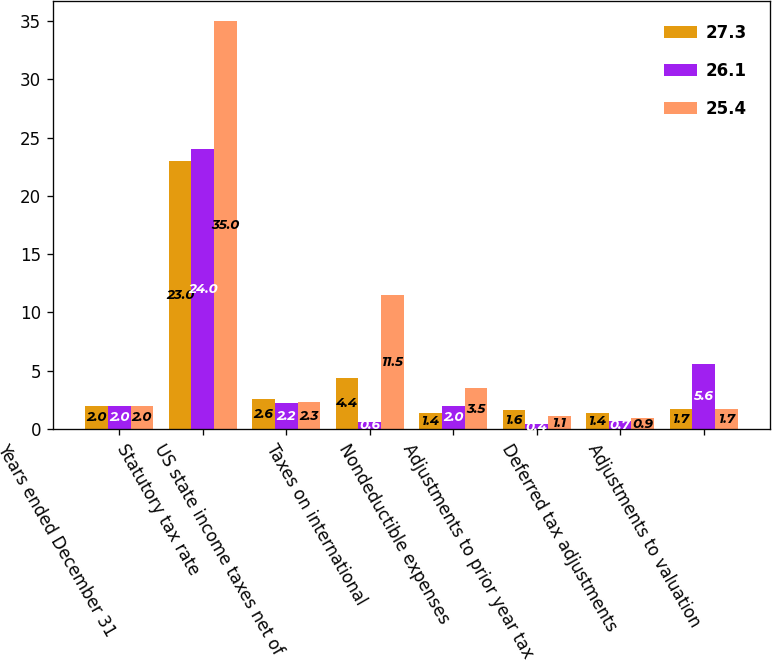Convert chart to OTSL. <chart><loc_0><loc_0><loc_500><loc_500><stacked_bar_chart><ecel><fcel>Years ended December 31<fcel>Statutory tax rate<fcel>US state income taxes net of<fcel>Taxes on international<fcel>Nondeductible expenses<fcel>Adjustments to prior year tax<fcel>Deferred tax adjustments<fcel>Adjustments to valuation<nl><fcel>27.3<fcel>2<fcel>23<fcel>2.6<fcel>4.4<fcel>1.4<fcel>1.6<fcel>1.4<fcel>1.7<nl><fcel>26.1<fcel>2<fcel>24<fcel>2.2<fcel>0.6<fcel>2<fcel>0.4<fcel>0.7<fcel>5.6<nl><fcel>25.4<fcel>2<fcel>35<fcel>2.3<fcel>11.5<fcel>3.5<fcel>1.1<fcel>0.9<fcel>1.7<nl></chart> 